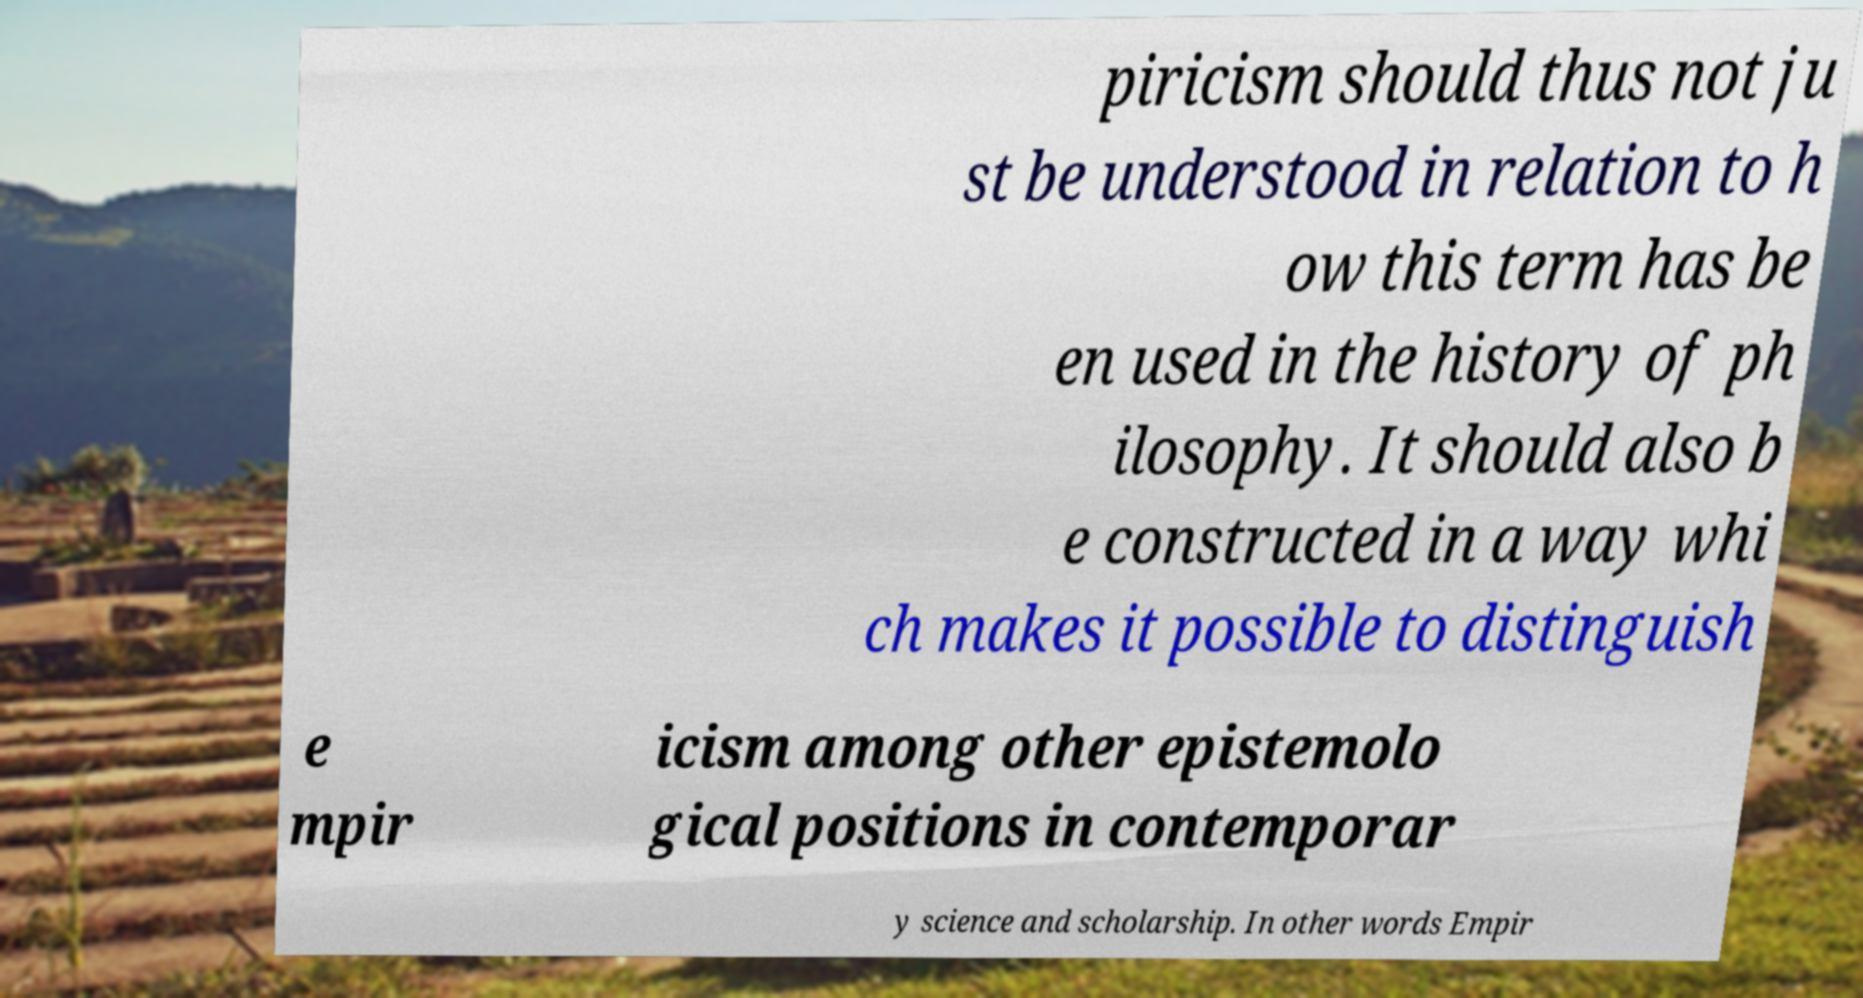Could you extract and type out the text from this image? piricism should thus not ju st be understood in relation to h ow this term has be en used in the history of ph ilosophy. It should also b e constructed in a way whi ch makes it possible to distinguish e mpir icism among other epistemolo gical positions in contemporar y science and scholarship. In other words Empir 